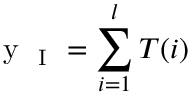<formula> <loc_0><loc_0><loc_500><loc_500>y _ { I } = \sum _ { i = 1 } ^ { l } T ( i )</formula> 